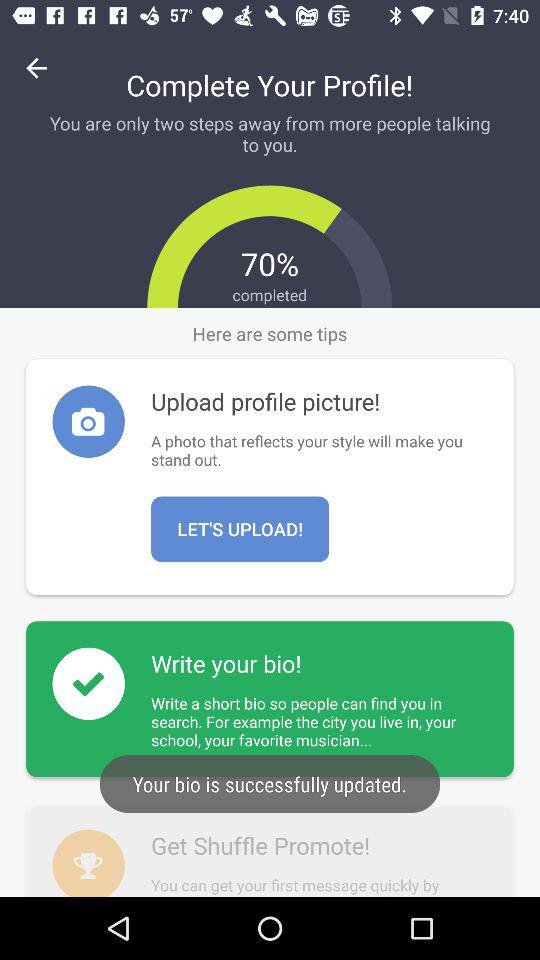How many steps are there left to complete the profile?
Answer the question using a single word or phrase. 2 